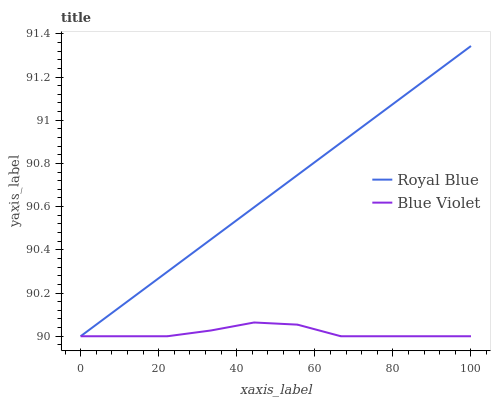Does Blue Violet have the maximum area under the curve?
Answer yes or no. No. Is Blue Violet the smoothest?
Answer yes or no. No. Does Blue Violet have the highest value?
Answer yes or no. No. 